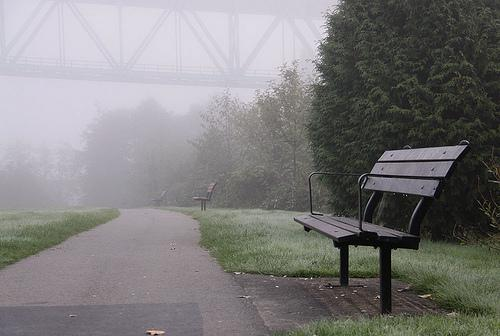In a few words, describe the weather conditions visible in this image. Partially foggy and calm weather. What type of road covers the middle part of the image, and what is on either side? The road is a black asphalt walkway, and it is surrounded by lush green grass on both sides. What are the benches made of and how many benches are there in the image? The benches are made of wood with black railings, and there are three benches. Identify an object on the pathway and describe its appearance. There is a dry leaf on the walkway, which appears to be slightly curled. Describe a distinct feature of the pathway in the image. The pathway is curved and stretches into the distance. How does the fog influence the visibility of the foliage in the distance? The foliage in the distance is obscured by the rolling fog. What objects can be found above the pathway in the image? A bridge goes over the pathway, and there are large trees behind the benches. What is unique about the benches and the surface they are positioned on? The benches are bolted to the ground and are positioned on cement. Indicate any observed interaction between the benches and their immediate surroundings. There are dry leaves beneath the bench, which seem to have fallen from the trees above. Identify the primary location of this image and describe the general atmosphere. This image is of a park with a walkway, benches, and greenery. The atmosphere is peaceful and slightly foggy, creating a serene setting. 